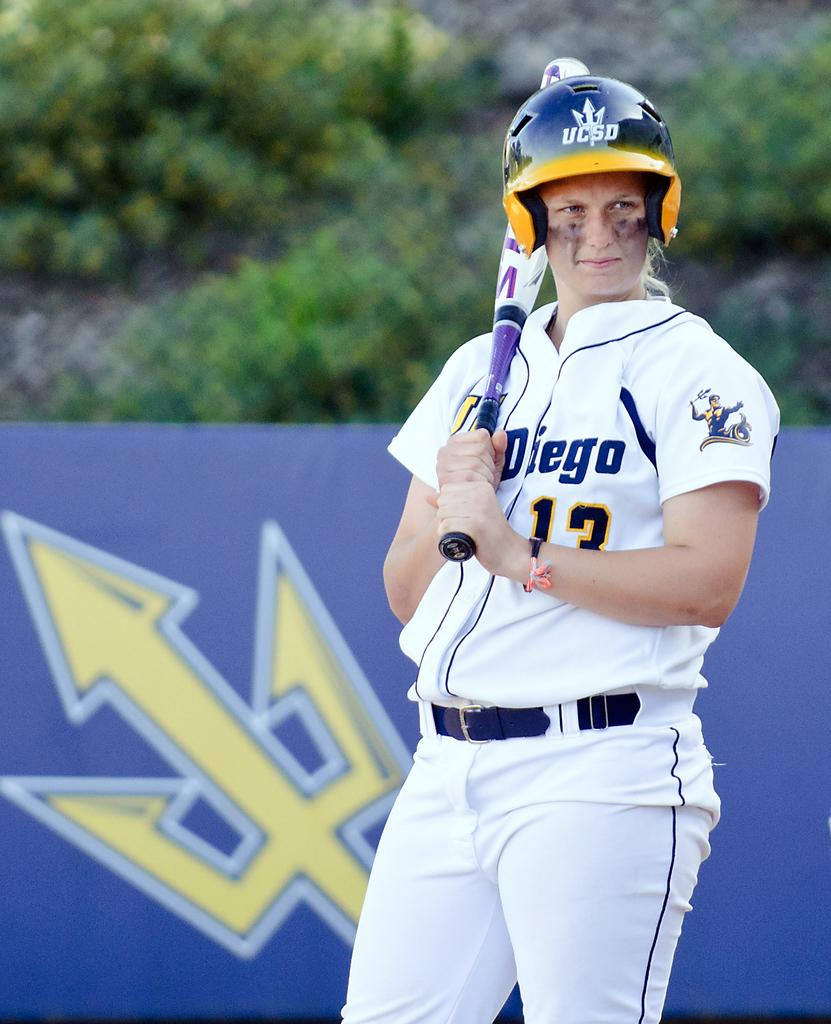What is the main subject of the image? There is a person in the image. What type of clothing is the person wearing? The person is wearing a sports dress. What object is the person holding? The person is holding a baseball bat. What can be seen in the image besides the person? There is a board and trees visible in the image. How would you describe the background of the image? The background of the image is blurred. Can you tell me how many dimes are on the board in the image? There are no dimes present on the board in the image. What type of needle is the person using to sew the sports dress in the image? There is no needle visible in the image, and the person is not sewing the sports dress. 